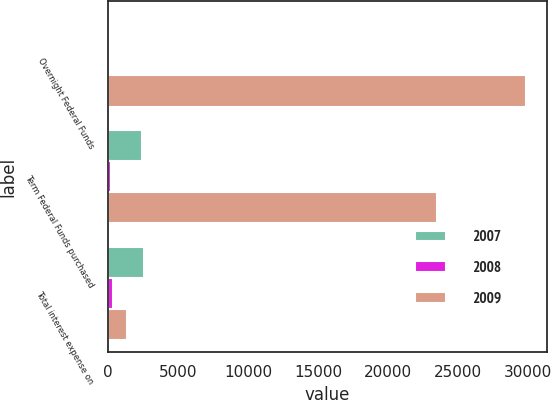Convert chart. <chart><loc_0><loc_0><loc_500><loc_500><stacked_bar_chart><ecel><fcel>Overnight Federal Funds<fcel>Term Federal Funds purchased<fcel>Total interest expense on<nl><fcel>2007<fcel>156<fcel>2382<fcel>2538<nl><fcel>2008<fcel>136<fcel>207<fcel>343<nl><fcel>2009<fcel>29840<fcel>23463<fcel>1362.5<nl></chart> 